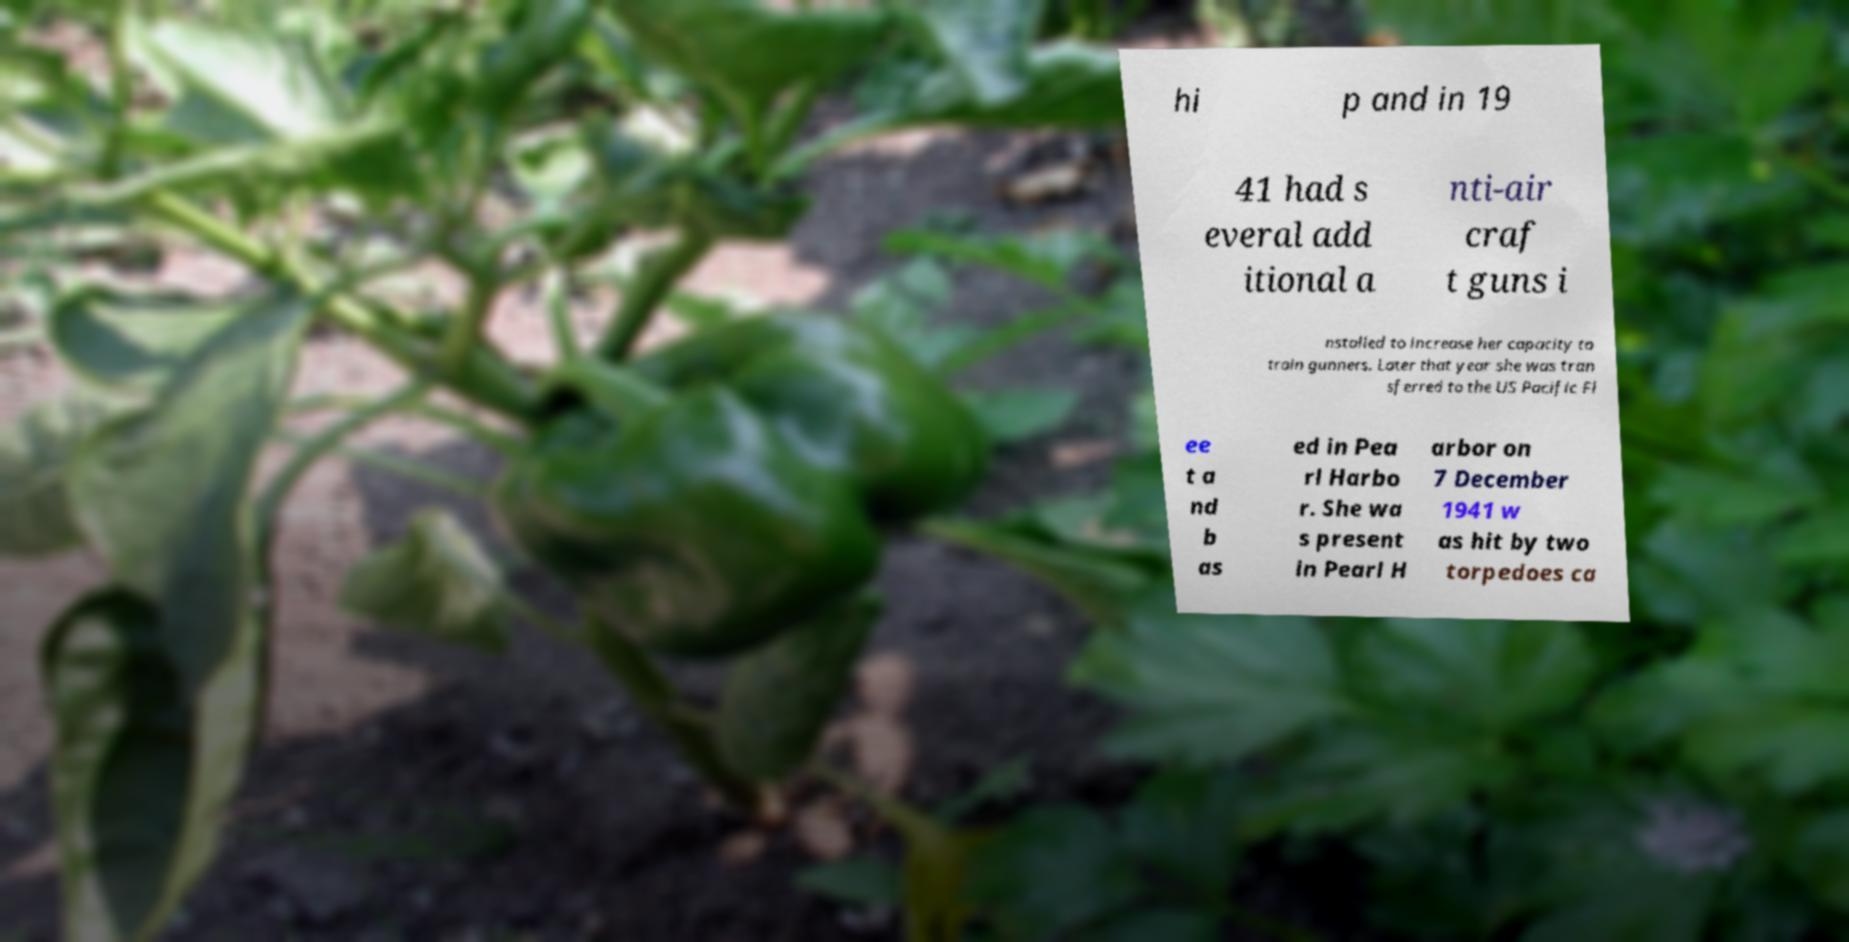Could you extract and type out the text from this image? hi p and in 19 41 had s everal add itional a nti-air craf t guns i nstalled to increase her capacity to train gunners. Later that year she was tran sferred to the US Pacific Fl ee t a nd b as ed in Pea rl Harbo r. She wa s present in Pearl H arbor on 7 December 1941 w as hit by two torpedoes ca 